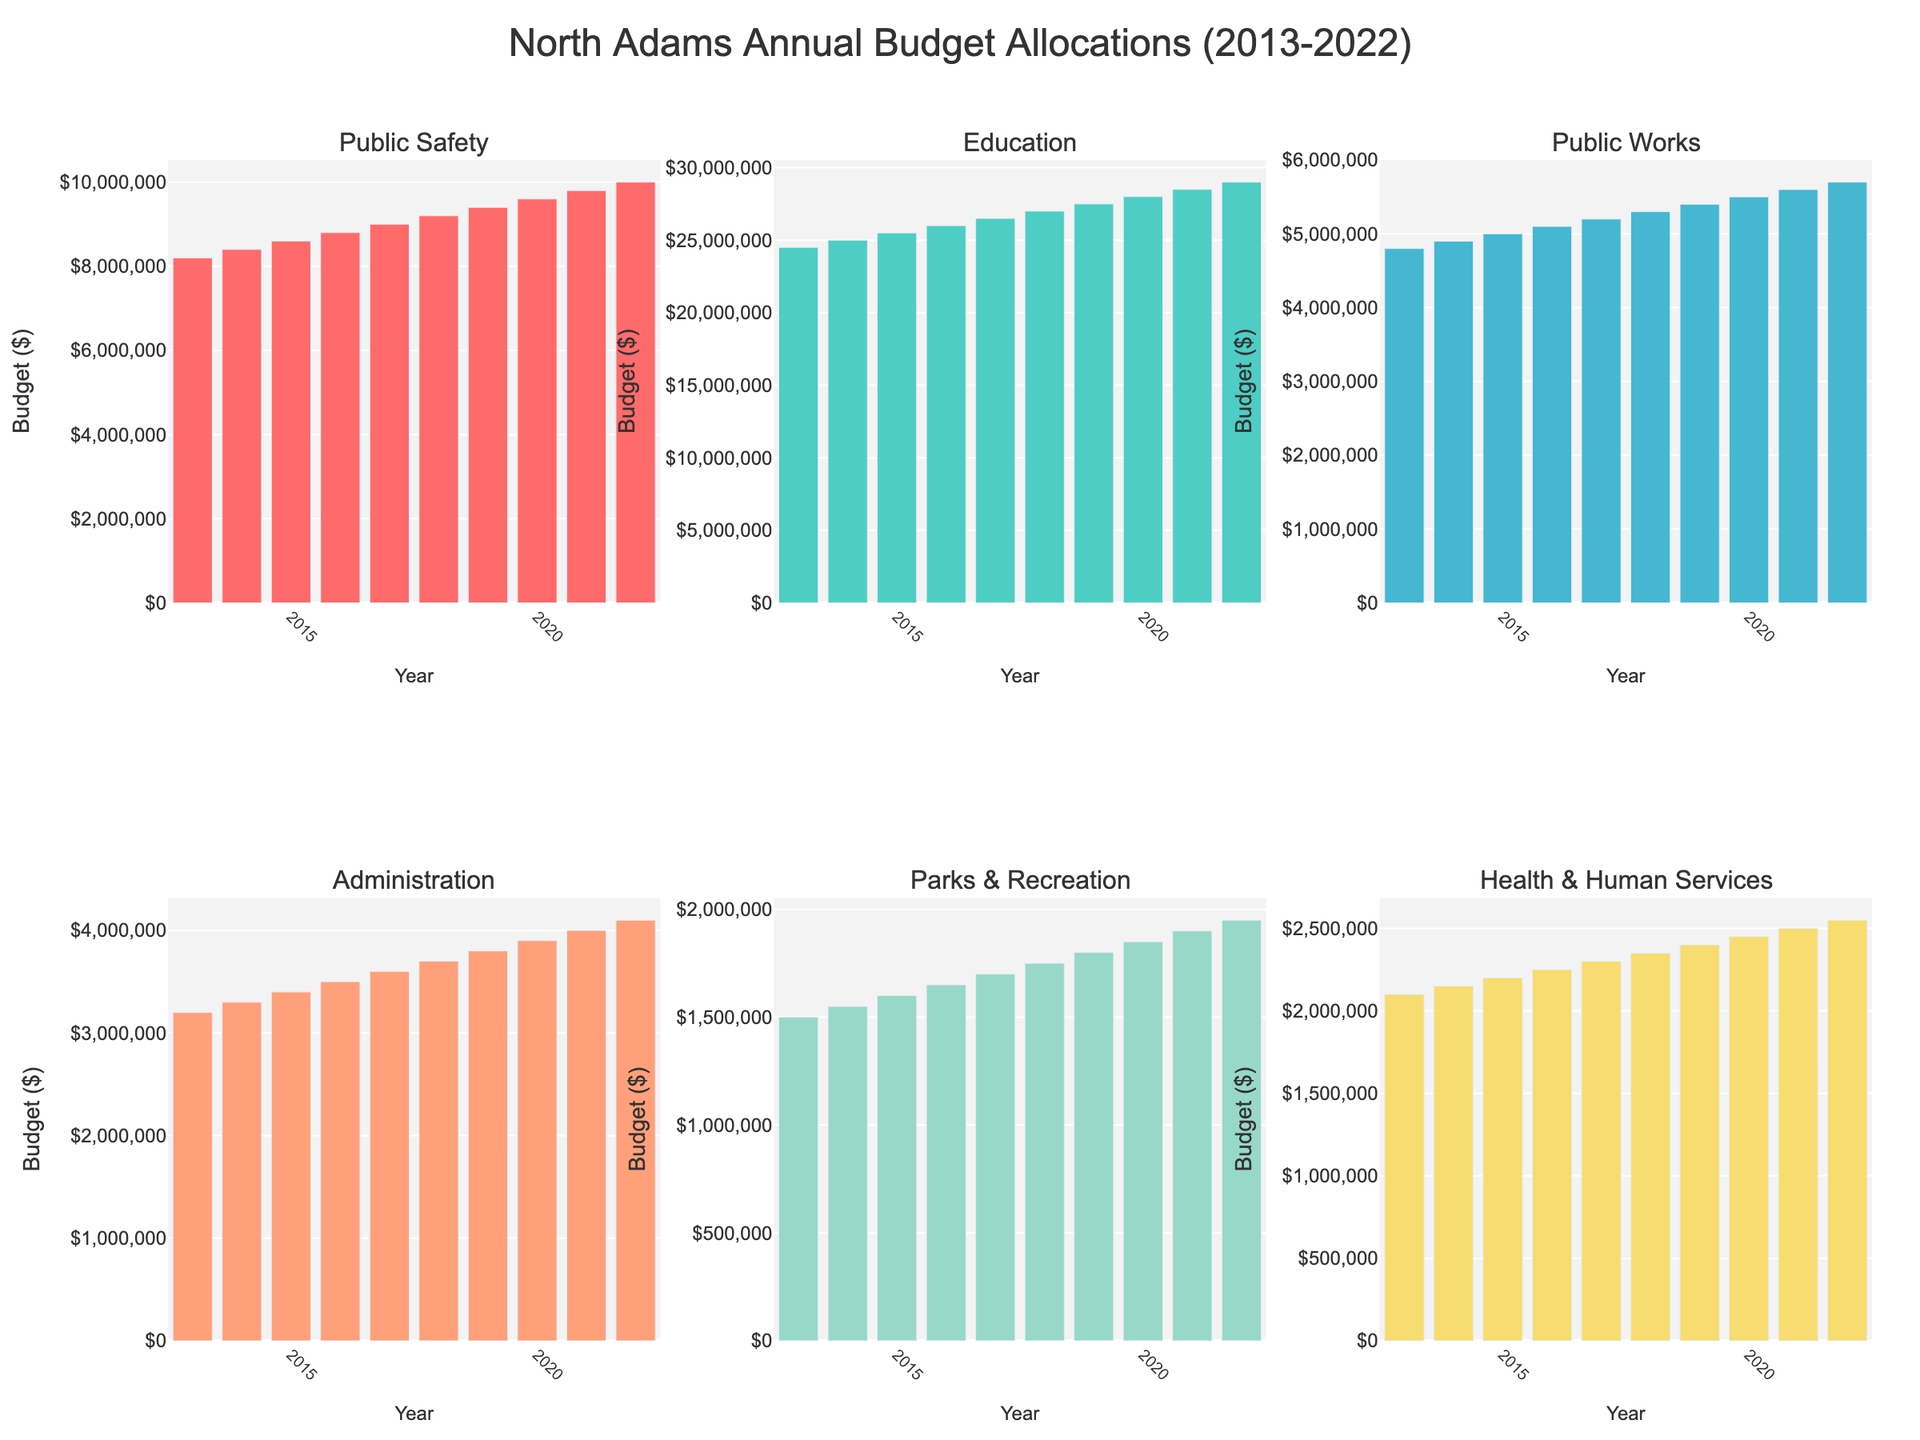Which department had the highest budget in 2022? By examining the height of the bars for each department in 2022, the tallest bar represents the highest budget. The Education department has the tallest bar.
Answer: Education What is the total budget allocated to Public Works from 2019 to 2022? Sum the budget values for Public Works for the years 2019, 2020, 2021, and 2022: 5400000 + 5500000 + 5600000 + 5700000 = 22200000
Answer: 22200000 Which department's budget increased the most from 2013 to 2022? Calculate the budget difference from 2013 to 2022 for each department and identify the maximum difference. Education: 29000000 - 24500000 = 4500000, Public Safety: 10000000 - 8200000 = 1800000, Public Works: 5700000 - 4800000 = 900000, Administration: 4100000 - 3200000 = 900000, Parks & Recreation: 1950000 - 1500000 = 450000, Health & Human Services: 2550000 - 2100000 = 450000. The Education department has the largest increase.
Answer: Education What's the average annual budget for Health & Human Services from 2013 to 2022? Calculate the sum of the budgets for Health & Human Services over the years 2013 to 2022, then divide by the number of years (10). Sum: 2100000 + 2150000 + 2200000 + 2250000 + 2300000 + 2350000 + 2400000 + 2450000 + 2500000 + 2550000 = 23250000. Average: 23250000 / 10 = 2325000
Answer: 2325000 Which two departments had equal budgets in any given year? Compare the budget values for all departments year by year to find any equal values. No departments had equal budgets in any given year.
Answer: None How much more was allocated to Education than to Public Works in 2020? Subtract the Public Works budget from the Education budget for 2020: 28000000 - 5500000 = 22500000
Answer: 22500000 What trend is visible in the Parks & Recreation budget over the years? Observe the height of the bars for Parks & Recreation from 2013 to 2022, which shows a consistent increase each year.
Answer: Consistent increase Which year saw the highest budget increase for Public Safety, and what was the change? Calculate the year-to-year differences in Public Safety budgets and identify the maximum increase. Differences: 2014-2013 = 200000, 2015-2014 = 200000, 2016-2015 = 200000, 2017-2016 = 200000, 2018-2017 = 200000, 2019-2018 = 200000, 2020-2019 = 200000, 2021-2020 = 200000, 2022-2021 = 200000. The highest increase was in each year, consistently by 200000.
Answer: Each year, by 200000 What was the difference between the highest and lowest budgets across all departments in 2017? Identify the highest and lowest budgets among all departments in 2017, then find the difference. Highest: Education (26500000), Lowest: Parks & Recreation (1700000). Difference: 26500000 - 1700000 = 24800000
Answer: 24800000 